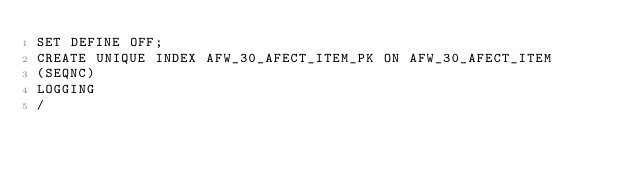<code> <loc_0><loc_0><loc_500><loc_500><_SQL_>SET DEFINE OFF;
CREATE UNIQUE INDEX AFW_30_AFECT_ITEM_PK ON AFW_30_AFECT_ITEM
(SEQNC)
LOGGING
/
</code> 